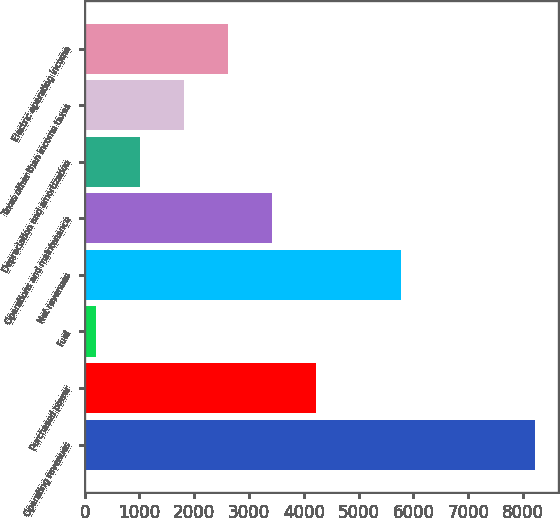Convert chart to OTSL. <chart><loc_0><loc_0><loc_500><loc_500><bar_chart><fcel>Operating revenues<fcel>Purchased power<fcel>Fuel<fcel>Net revenues<fcel>Operations and maintenance<fcel>Depreciation and amortization<fcel>Taxes other than income taxes<fcel>Electric operating income<nl><fcel>8228<fcel>4213.5<fcel>199<fcel>5769<fcel>3410.6<fcel>1001.9<fcel>1804.8<fcel>2607.7<nl></chart> 